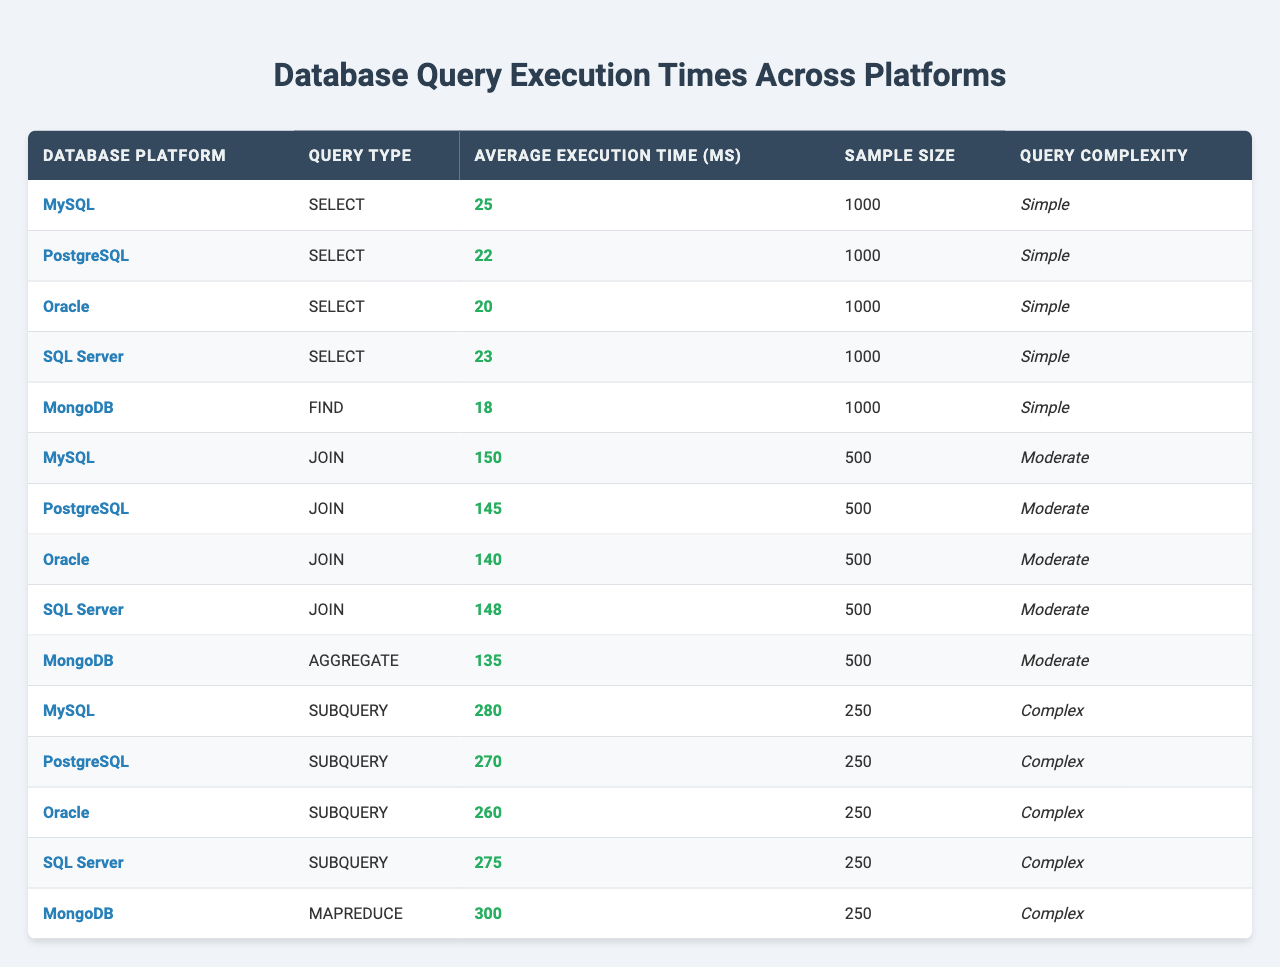What is the average execution time of SELECT queries across all platforms? The average execution times for SELECT queries are: MySQL (25 ms), PostgreSQL (22 ms), Oracle (20 ms), and SQL Server (23 ms). Summing these gives 25 + 22 + 20 + 23 = 90 ms. Dividing by 4 (the number of platforms) gives 90 / 4 = 22.5 ms.
Answer: 22.5 ms Which database platform has the fastest JOIN execution time? The execution times for JOIN queries are: MySQL (150 ms), PostgreSQL (145 ms), Oracle (140 ms), SQL Server (148 ms). The lowest value is from Oracle at 140 ms.
Answer: Oracle Is MongoDB faster than PostgreSQL for FIND queries? The execution times are: MongoDB (18 ms) and PostgreSQL (22 ms). Since 18 is less than 22, MongoDB is indeed faster.
Answer: Yes What is the execution time difference between the slowest and fastest SUBQUERY execution times? The execution times for SUBQUERY queries are: MySQL (280 ms), PostgreSQL (270 ms), Oracle (260 ms), SQL Server (275 ms), and MongoDB (300 ms). The fastest is Oracle at 260 ms and the slowest is MongoDB at 300 ms. The difference is 300 - 260 = 40 ms.
Answer: 40 ms How many platforms have an execution time of more than 150 ms for JOIN queries? The execution times for JOIN queries are: MySQL (150 ms), PostgreSQL (145 ms), Oracle (140 ms), SQL Server (148 ms). Only MySQL has an execution time exactly at 150 ms, and none exceed 150 ms.
Answer: 0 What percentage of platforms have a query complexity classified as "Complex"? There are 5 platforms in total, and 5 of them (MySQL, PostgreSQL, Oracle, SQL Server, MongoDB) have a complexity of "Complex." Therefore, the percentage is (5 / 5) * 100 = 100%.
Answer: 100% Which query type has the highest average execution time, and what is that time? The query types and execution times are: SUBQUERY is 280 ms (MySQL), 270 ms (PostgreSQL), 260 ms (Oracle), 275 ms (SQL Server), 300 ms (MongoDB). The highest is from MongoDB at 300 ms for MAPREDUCE.
Answer: 300 ms For which query type does PostgreSQL show the closest execution time to Oracle? PostgreSQL's JOIN is 145 ms and Oracle's JOIN is 140 ms. Therefore, the closest execution time between PostgreSQL and Oracle is for JOIN queries, with a difference of 5 ms.
Answer: JOIN What is the most time-consuming query type in MySQL? In MySQL, the query types and execution times are SELECT (25 ms), JOIN (150 ms), and SUBQUERY (280 ms). The SUBQUERY type is the most time-consuming at 280 ms.
Answer: SUBQUERY Is it true that SQL Server performs better than Oracle for SELECT queries? SQL Server has an execution time of 23 ms for SELECT queries, while Oracle has 20 ms. Since 23 is greater than 20, SQL Server does not perform better.
Answer: No 